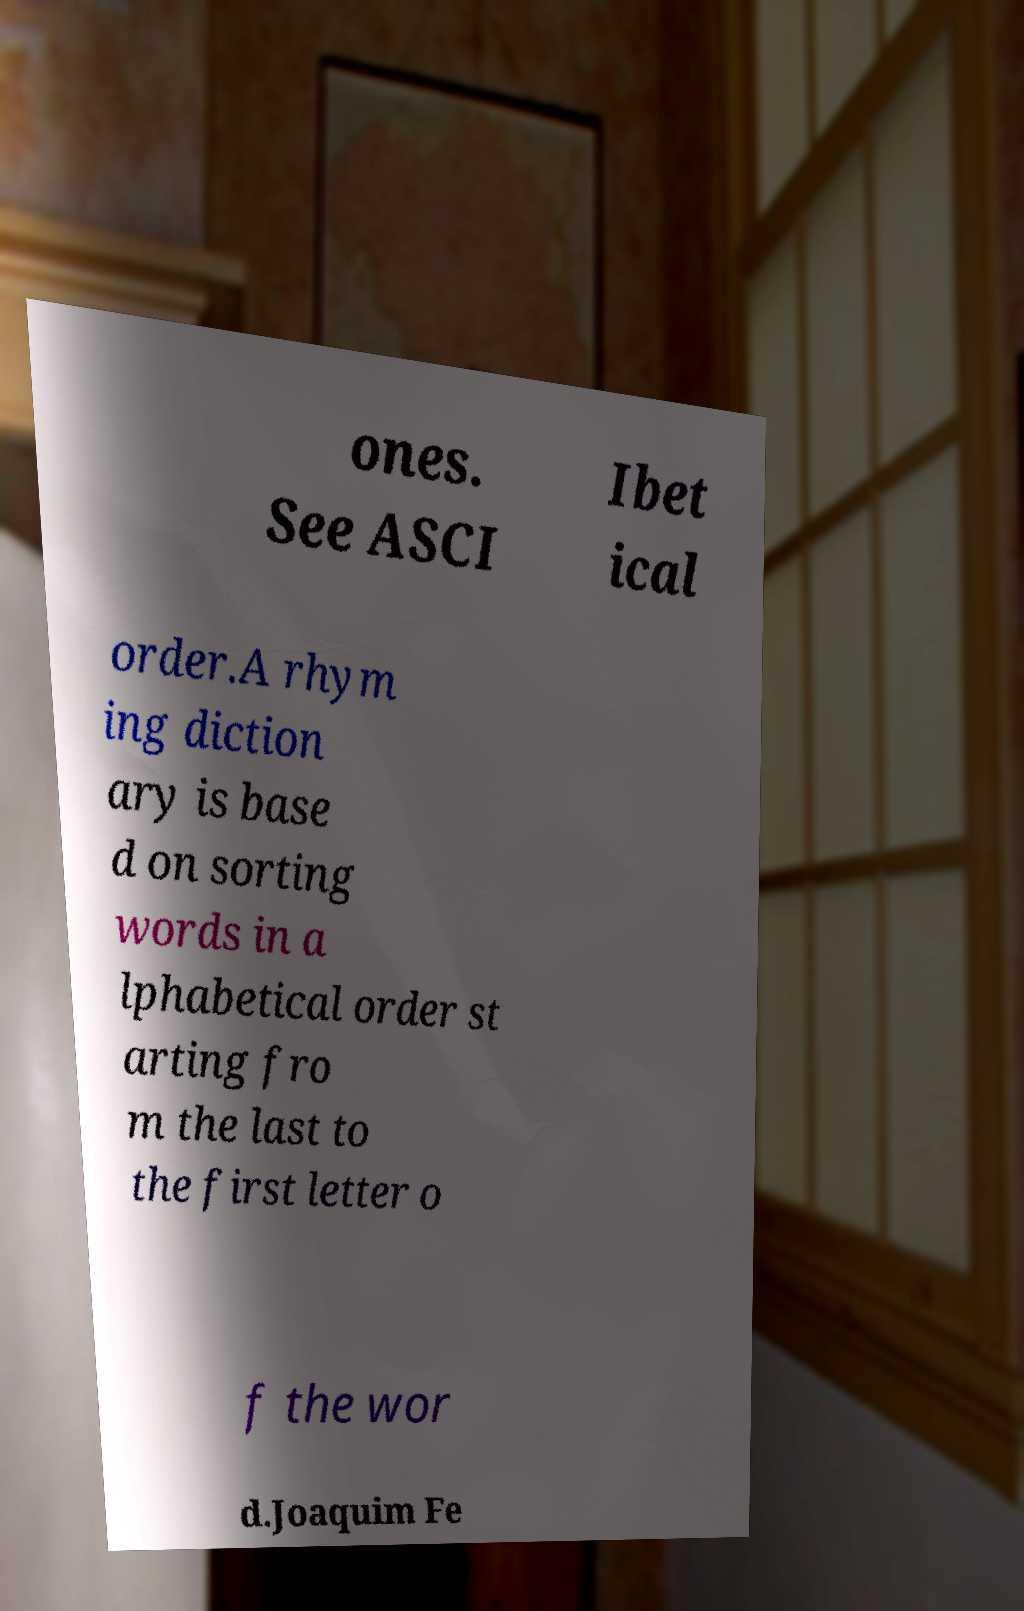Please identify and transcribe the text found in this image. ones. See ASCI Ibet ical order.A rhym ing diction ary is base d on sorting words in a lphabetical order st arting fro m the last to the first letter o f the wor d.Joaquim Fe 